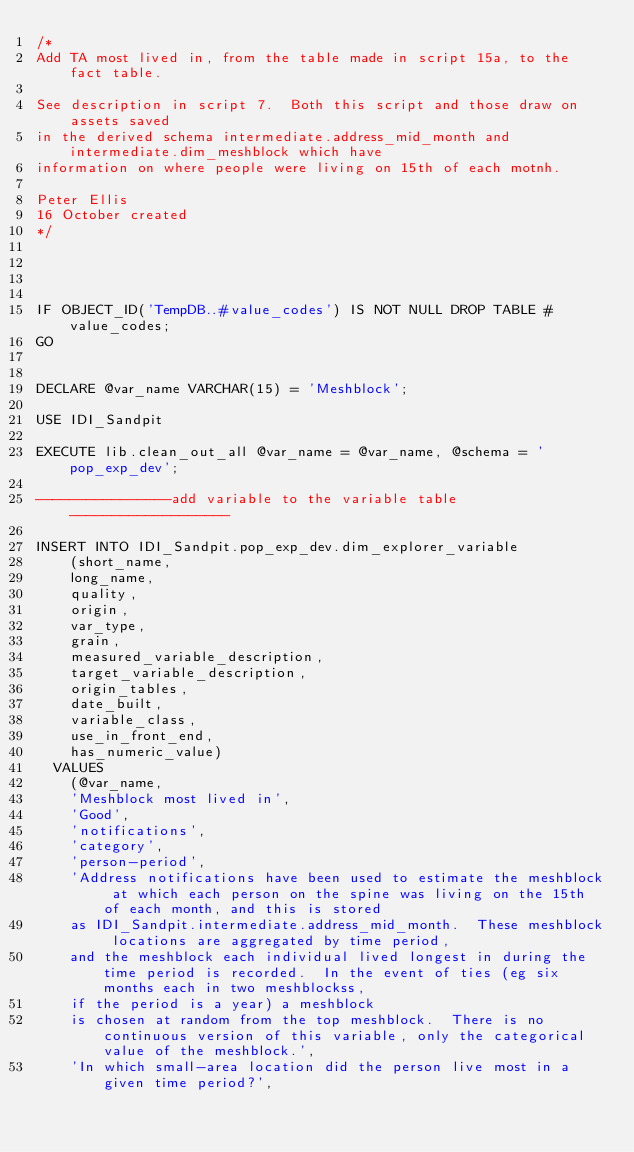<code> <loc_0><loc_0><loc_500><loc_500><_SQL_>/*
Add TA most lived in, from the table made in script 15a, to the fact table.

See description in script 7.  Both this script and those draw on assets saved
in the derived schema intermediate.address_mid_month and intermediate.dim_meshblock which have
information on where people were living on 15th of each motnh.

Peter Ellis 
16 October created
*/




IF OBJECT_ID('TempDB..#value_codes') IS NOT NULL DROP TABLE #value_codes;
GO 


DECLARE @var_name VARCHAR(15) = 'Meshblock';

USE IDI_Sandpit

EXECUTE lib.clean_out_all @var_name = @var_name, @schema = 'pop_exp_dev';

----------------add variable to the variable table-------------------

INSERT INTO IDI_Sandpit.pop_exp_dev.dim_explorer_variable
		(short_name, 
		long_name,
		quality,
		origin,
		var_type,
		grain,
		measured_variable_description,
		target_variable_description,
		origin_tables,
		date_built,
		variable_class,
		use_in_front_end,
		has_numeric_value) 
	VALUES   
		(@var_name,
		'Meshblock most lived in',
		'Good',
		'notifications',
		'category',
		'person-period',
		'Address notifications have been used to estimate the meshblock at which each person on the spine was living on the 15th of each month, and this is stored 
		as IDI_Sandpit.intermediate.address_mid_month.  These meshblock locations are aggregated by time period, 
		and the meshblock each individual lived longest in during the time period is recorded.  In the event of ties (eg six months each in two meshblockss, 
		if the period is a year) a meshblock 
		is chosen at random from the top meshblock.  There is no continuous version of this variable, only the categorical value of the meshblock.',
		'In which small-area location did the person live most in a given time period?',</code> 